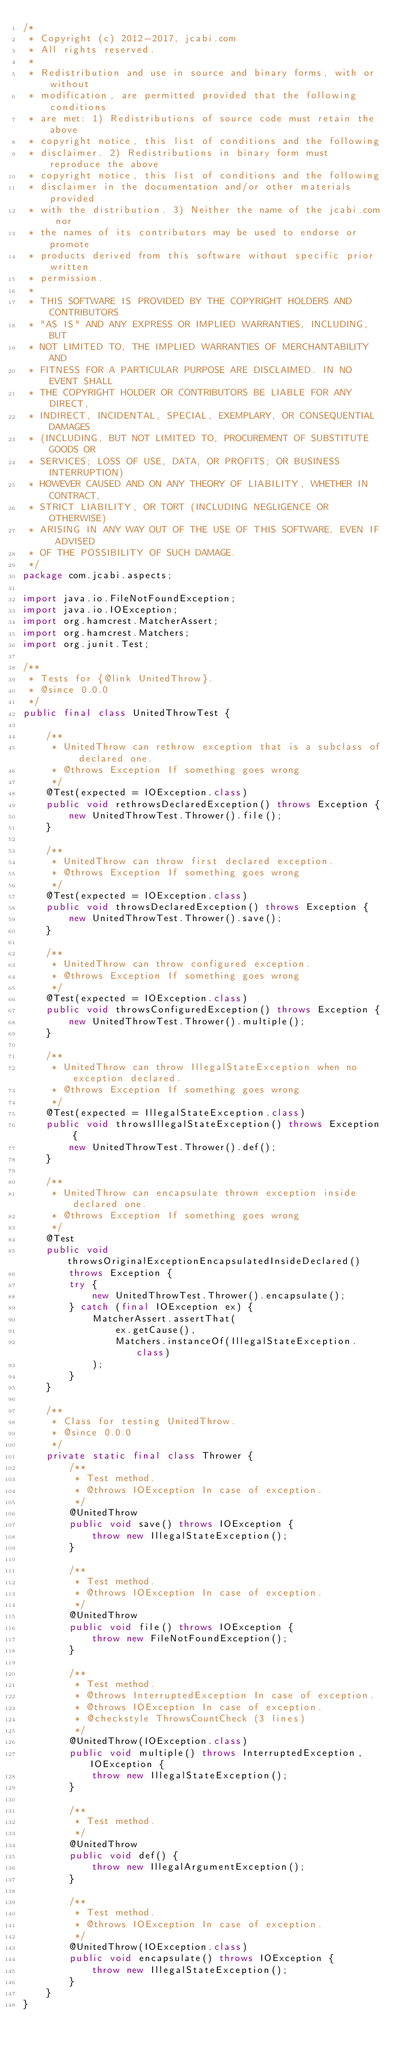<code> <loc_0><loc_0><loc_500><loc_500><_Java_>/*
 * Copyright (c) 2012-2017, jcabi.com
 * All rights reserved.
 *
 * Redistribution and use in source and binary forms, with or without
 * modification, are permitted provided that the following conditions
 * are met: 1) Redistributions of source code must retain the above
 * copyright notice, this list of conditions and the following
 * disclaimer. 2) Redistributions in binary form must reproduce the above
 * copyright notice, this list of conditions and the following
 * disclaimer in the documentation and/or other materials provided
 * with the distribution. 3) Neither the name of the jcabi.com nor
 * the names of its contributors may be used to endorse or promote
 * products derived from this software without specific prior written
 * permission.
 *
 * THIS SOFTWARE IS PROVIDED BY THE COPYRIGHT HOLDERS AND CONTRIBUTORS
 * "AS IS" AND ANY EXPRESS OR IMPLIED WARRANTIES, INCLUDING, BUT
 * NOT LIMITED TO, THE IMPLIED WARRANTIES OF MERCHANTABILITY AND
 * FITNESS FOR A PARTICULAR PURPOSE ARE DISCLAIMED. IN NO EVENT SHALL
 * THE COPYRIGHT HOLDER OR CONTRIBUTORS BE LIABLE FOR ANY DIRECT,
 * INDIRECT, INCIDENTAL, SPECIAL, EXEMPLARY, OR CONSEQUENTIAL DAMAGES
 * (INCLUDING, BUT NOT LIMITED TO, PROCUREMENT OF SUBSTITUTE GOODS OR
 * SERVICES; LOSS OF USE, DATA, OR PROFITS; OR BUSINESS INTERRUPTION)
 * HOWEVER CAUSED AND ON ANY THEORY OF LIABILITY, WHETHER IN CONTRACT,
 * STRICT LIABILITY, OR TORT (INCLUDING NEGLIGENCE OR OTHERWISE)
 * ARISING IN ANY WAY OUT OF THE USE OF THIS SOFTWARE, EVEN IF ADVISED
 * OF THE POSSIBILITY OF SUCH DAMAGE.
 */
package com.jcabi.aspects;

import java.io.FileNotFoundException;
import java.io.IOException;
import org.hamcrest.MatcherAssert;
import org.hamcrest.Matchers;
import org.junit.Test;

/**
 * Tests for {@link UnitedThrow}.
 * @since 0.0.0
 */
public final class UnitedThrowTest {

    /**
     * UnitedThrow can rethrow exception that is a subclass of declared one.
     * @throws Exception If something goes wrong
     */
    @Test(expected = IOException.class)
    public void rethrowsDeclaredException() throws Exception {
        new UnitedThrowTest.Thrower().file();
    }

    /**
     * UnitedThrow can throw first declared exception.
     * @throws Exception If something goes wrong
     */
    @Test(expected = IOException.class)
    public void throwsDeclaredException() throws Exception {
        new UnitedThrowTest.Thrower().save();
    }

    /**
     * UnitedThrow can throw configured exception.
     * @throws Exception If something goes wrong
     */
    @Test(expected = IOException.class)
    public void throwsConfiguredException() throws Exception {
        new UnitedThrowTest.Thrower().multiple();
    }

    /**
     * UnitedThrow can throw IllegalStateException when no exception declared.
     * @throws Exception If something goes wrong
     */
    @Test(expected = IllegalStateException.class)
    public void throwsIllegalStateException() throws Exception {
        new UnitedThrowTest.Thrower().def();
    }

    /**
     * UnitedThrow can encapsulate thrown exception inside declared one.
     * @throws Exception If something goes wrong
     */
    @Test
    public void throwsOriginalExceptionEncapsulatedInsideDeclared()
        throws Exception {
        try {
            new UnitedThrowTest.Thrower().encapsulate();
        } catch (final IOException ex) {
            MatcherAssert.assertThat(
                ex.getCause(),
                Matchers.instanceOf(IllegalStateException.class)
            );
        }
    }

    /**
     * Class for testing UnitedThrow.
     * @since 0.0.0
     */
    private static final class Thrower {
        /**
         * Test method.
         * @throws IOException In case of exception.
         */
        @UnitedThrow
        public void save() throws IOException {
            throw new IllegalStateException();
        }

        /**
         * Test method.
         * @throws IOException In case of exception.
         */
        @UnitedThrow
        public void file() throws IOException {
            throw new FileNotFoundException();
        }

        /**
         * Test method.
         * @throws InterruptedException In case of exception.
         * @throws IOException In case of exception.
         * @checkstyle ThrowsCountCheck (3 lines)
         */
        @UnitedThrow(IOException.class)
        public void multiple() throws InterruptedException, IOException {
            throw new IllegalStateException();
        }

        /**
         * Test method.
         */
        @UnitedThrow
        public void def() {
            throw new IllegalArgumentException();
        }

        /**
         * Test method.
         * @throws IOException In case of exception.
         */
        @UnitedThrow(IOException.class)
        public void encapsulate() throws IOException {
            throw new IllegalStateException();
        }
    }
}
</code> 